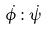<formula> <loc_0><loc_0><loc_500><loc_500>\dot { \phi } \colon \dot { \psi }</formula> 